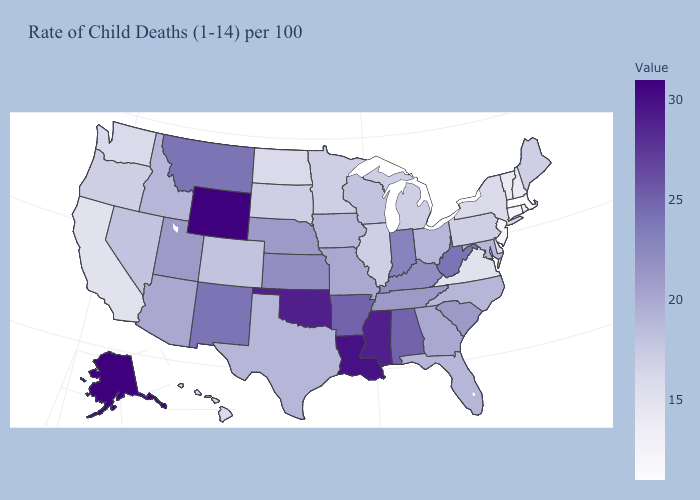Among the states that border Georgia , which have the highest value?
Keep it brief. Alabama. Does Tennessee have the highest value in the USA?
Short answer required. No. Which states have the highest value in the USA?
Quick response, please. Alaska, Wyoming. Does Ohio have a higher value than Virginia?
Write a very short answer. Yes. Which states have the lowest value in the USA?
Write a very short answer. Massachusetts. Among the states that border Montana , which have the highest value?
Short answer required. Wyoming. 